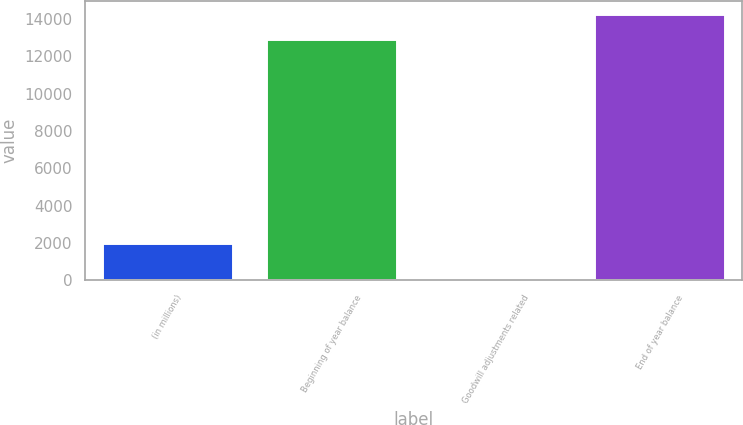Convert chart. <chart><loc_0><loc_0><loc_500><loc_500><bar_chart><fcel>(in millions)<fcel>Beginning of year balance<fcel>Goodwill adjustments related<fcel>End of year balance<nl><fcel>2015<fcel>12961<fcel>19<fcel>14271.4<nl></chart> 